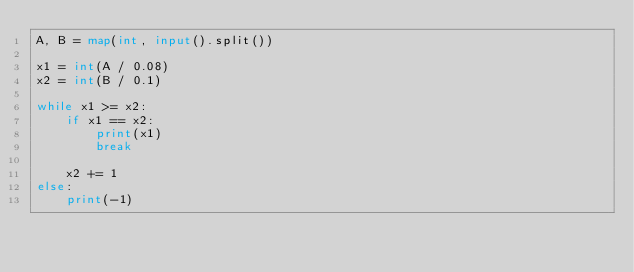Convert code to text. <code><loc_0><loc_0><loc_500><loc_500><_Python_>A, B = map(int, input().split())

x1 = int(A / 0.08)
x2 = int(B / 0.1)

while x1 >= x2:
    if x1 == x2:
        print(x1)
        break

    x2 += 1
else:
    print(-1)
</code> 